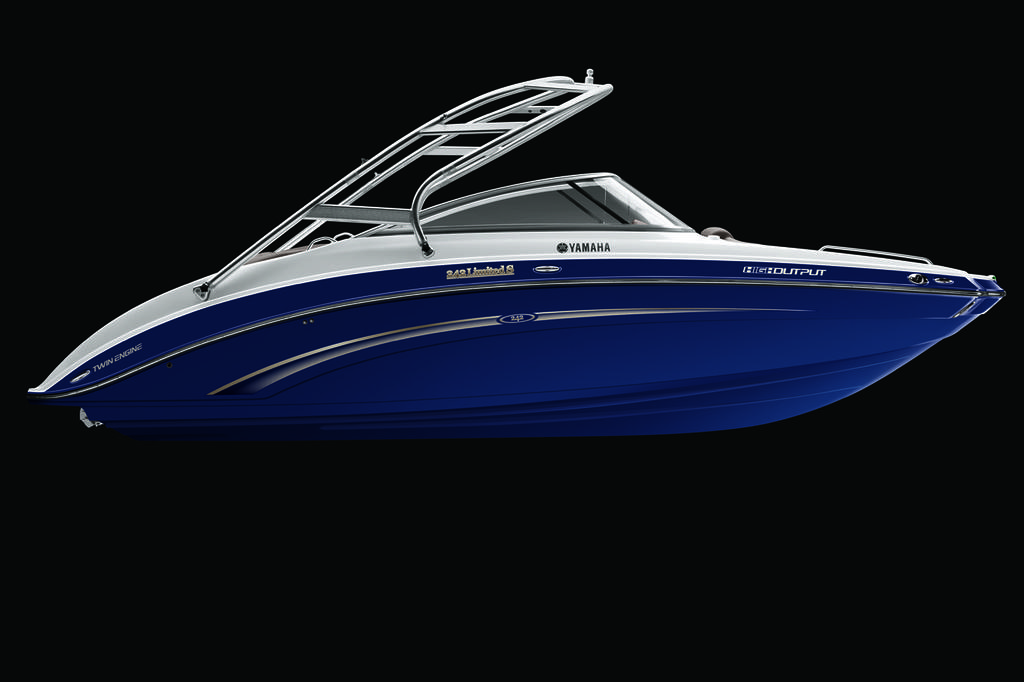What is the main subject of the image? There is a boat in the image. Where are the ants carrying the pancake in the image? There are no ants or pancakes present in the image; it features a boat. 